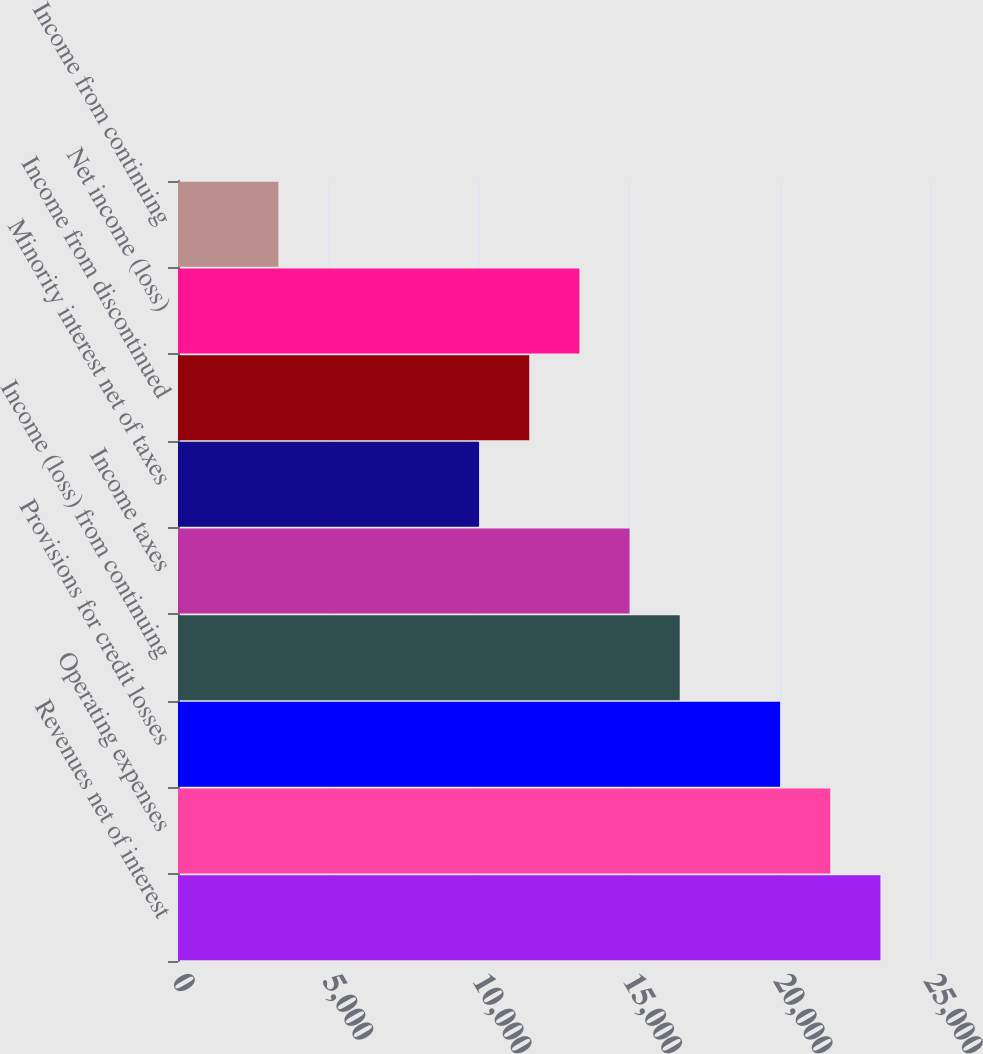<chart> <loc_0><loc_0><loc_500><loc_500><bar_chart><fcel>Revenues net of interest<fcel>Operating expenses<fcel>Provisions for credit losses<fcel>Income (loss) from continuing<fcel>Income taxes<fcel>Minority interest net of taxes<fcel>Income from discontinued<fcel>Net income (loss)<fcel>Income from continuing<nl><fcel>23351.9<fcel>21683.9<fcel>20016<fcel>16680<fcel>15012<fcel>10008.1<fcel>11676.1<fcel>13344.1<fcel>3336.26<nl></chart> 